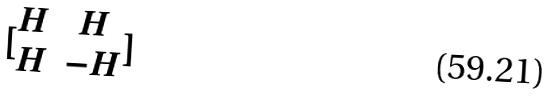Convert formula to latex. <formula><loc_0><loc_0><loc_500><loc_500>[ \begin{matrix} H & H \\ H & - H \end{matrix} ]</formula> 